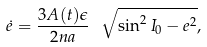<formula> <loc_0><loc_0><loc_500><loc_500>\dot { e } = \frac { 3 A ( t ) \epsilon } { 2 n a } \ \, \sqrt { \sin ^ { 2 } I _ { 0 } - e ^ { 2 } } ,</formula> 